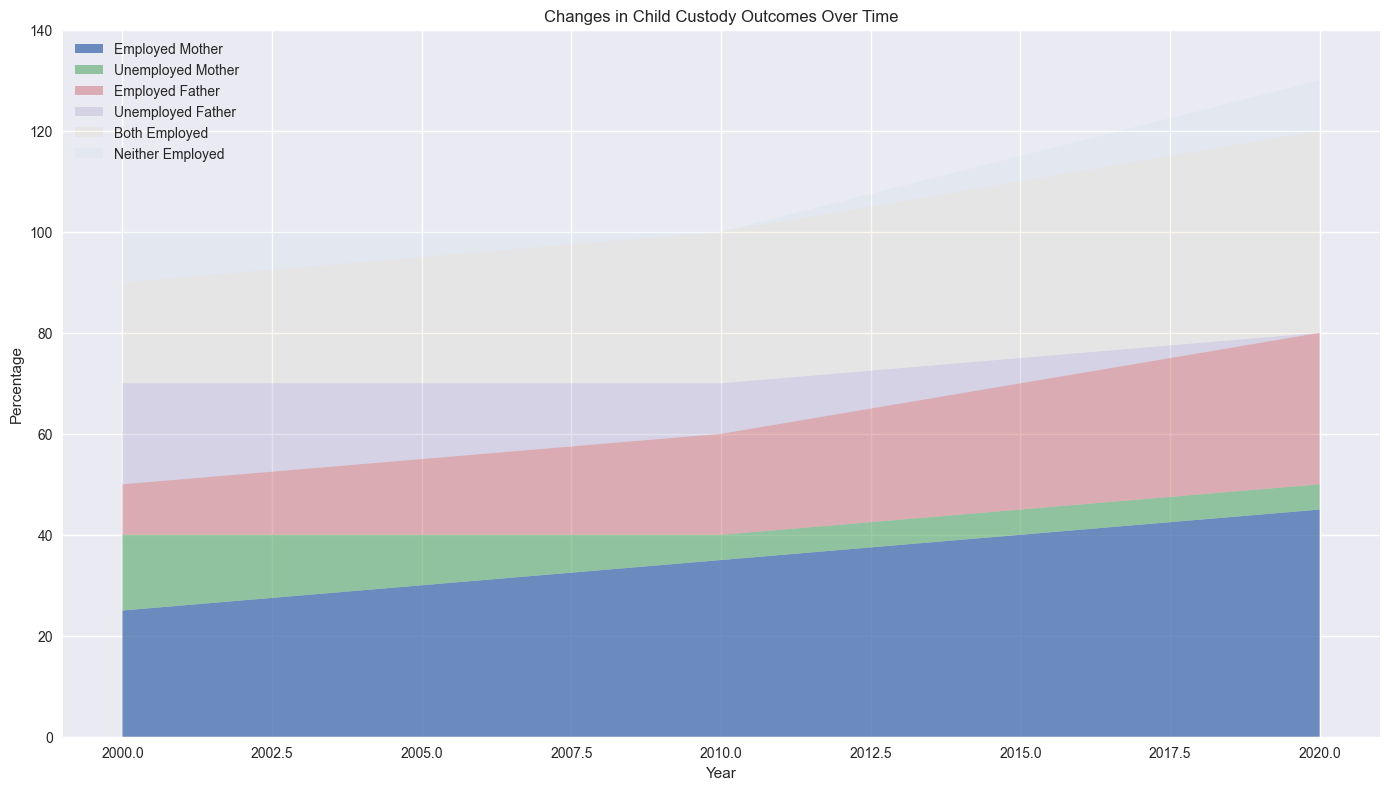What trends do you notice in the custody outcomes for employed mothers over the years? The area representing employed mothers has been increasing steadily from 25% in 2000 to 45% in 2020. This indicates a positive trend where the likelihood of custody outcomes favoring employed mothers has been rising consistently over the years.
Answer: The custody outcomes for employed mothers have increased steadily over the years Which group had the highest custody outcomes in 2020? By looking at the heights of the areas in 2020, employed mothers have the highest area at 45%.
Answer: Employed mothers How did the custody outcomes for unemployed mothers change over the years? The area representing unemployed mothers has been decreasing. It started at 15% in 2000 and dropped to 5% around 2010 and then remained stable at 5%.
Answer: Decreased from 15% to 5% In what year did the combined outcomes for both employed parents exceed outcomes for employed fathers alone? Adding the areas of both employed parents and comparing with employed fathers, we notice that combined outcomes for both employed parents (20% in 2000) exceed employed father alone (10% in 2000).
Answer: 2000 Compare the custody outcomes between employed fathers and unemployed fathers in 2010. In 2010, the area for employed fathers is 20%, whereas for unemployed fathers, it is 10%. This shows that employed fathers had a higher custody percentage compared to unemployed fathers in that year.
Answer: Employed fathers had higher custody outcomes What is the difference in custody outcomes between 2000 and 2020 for families where both parents are employed? In 2000, families with both parents employed had a 20% outcome. In 2020, this increased to 40%. The difference is 40% - 20% = 20%.
Answer: 20% How did the custody outcomes of neither employed parents change over the years? The area representing neither employed parents decreased from 10% in 2000 to 0% in 2010, then slightly increased to 10% by 2020.
Answer: Decreased initially, then increased Compare the custody outcomes for employed fathers and unemployed mothers in 2015. In 2015, employed fathers had a 25% outcome, and unemployed mothers had a 5% outcome. Employed fathers had significantly higher outcomes.
Answer: Employed fathers had higher outcomes What is the trend for single employed fathers from 2000 to 2020? The area for employed fathers has been increasing from 10% in 2000 to 30% in 2020, showing a consistent upward trend.
Answer: Increasing trend In which year did the custody outcomes for employed mothers equal the combined total of unemployed mothers and employed fathers? In 2011, employed mothers had 36% while unemployed mothers and employed fathers combined are 5%+21% = 26%. Therefore, in 2012 where employed mothers had 37% which nearly equals the value of the combination of unemployed mothers and employed fathers.
Answer: 2012 